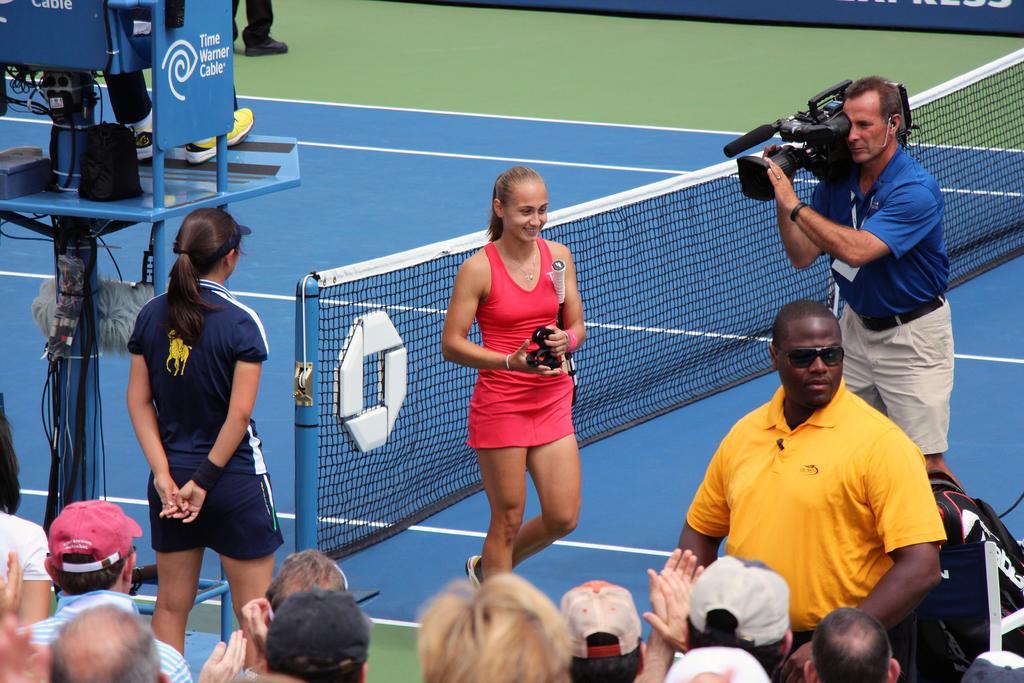Could you give a brief overview of what you see in this image? On the right side there is a person holding a video camera. Near to him a lady is holding a bat and some other thing in the hand. There are many people. Some are wearing cap. Also there is a person wearing yellow t shirt is wearing a goggles. There is a tennis court with net. On the left side there is a chair on a pole. On that a person is sitting. 